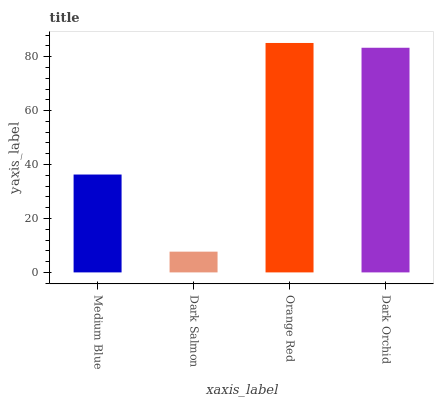Is Dark Salmon the minimum?
Answer yes or no. Yes. Is Orange Red the maximum?
Answer yes or no. Yes. Is Orange Red the minimum?
Answer yes or no. No. Is Dark Salmon the maximum?
Answer yes or no. No. Is Orange Red greater than Dark Salmon?
Answer yes or no. Yes. Is Dark Salmon less than Orange Red?
Answer yes or no. Yes. Is Dark Salmon greater than Orange Red?
Answer yes or no. No. Is Orange Red less than Dark Salmon?
Answer yes or no. No. Is Dark Orchid the high median?
Answer yes or no. Yes. Is Medium Blue the low median?
Answer yes or no. Yes. Is Medium Blue the high median?
Answer yes or no. No. Is Dark Orchid the low median?
Answer yes or no. No. 